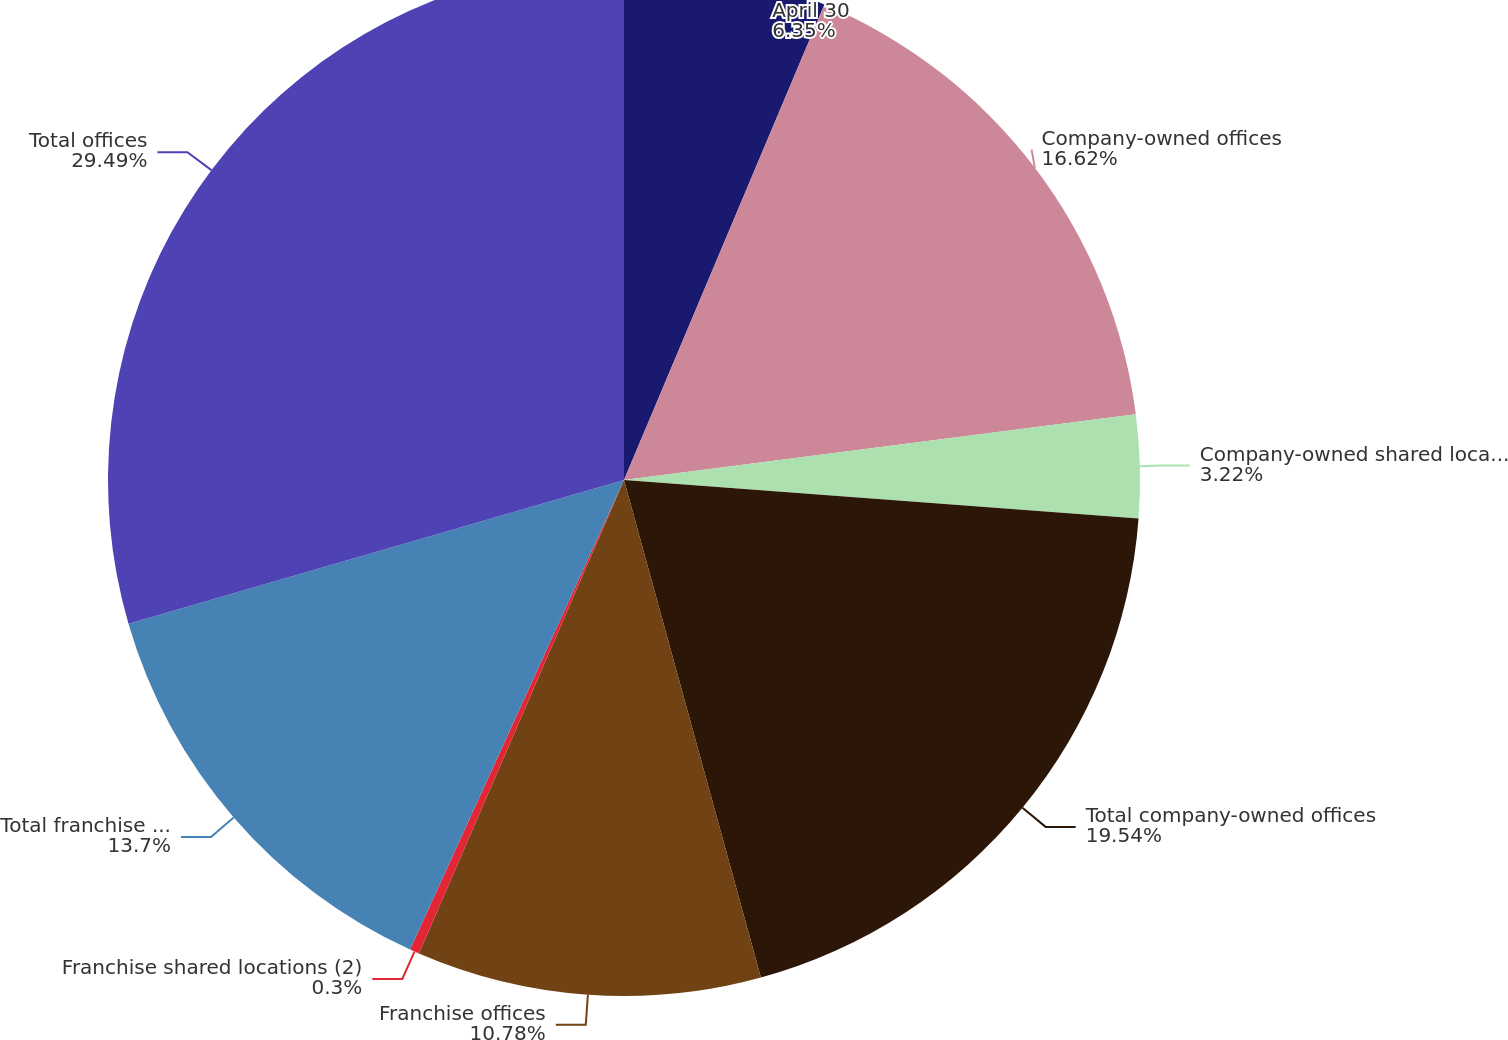Convert chart. <chart><loc_0><loc_0><loc_500><loc_500><pie_chart><fcel>April 30<fcel>Company-owned offices<fcel>Company-owned shared locations<fcel>Total company-owned offices<fcel>Franchise offices<fcel>Franchise shared locations (2)<fcel>Total franchise offices<fcel>Total offices<nl><fcel>6.35%<fcel>16.62%<fcel>3.22%<fcel>19.54%<fcel>10.78%<fcel>0.3%<fcel>13.7%<fcel>29.5%<nl></chart> 